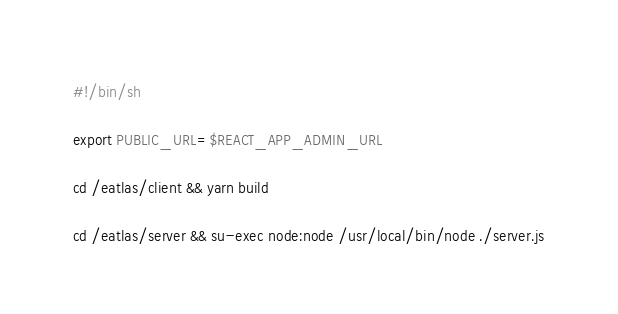<code> <loc_0><loc_0><loc_500><loc_500><_Bash_>#!/bin/sh

export PUBLIC_URL=$REACT_APP_ADMIN_URL

cd /eatlas/client && yarn build

cd /eatlas/server && su-exec node:node /usr/local/bin/node ./server.js
</code> 